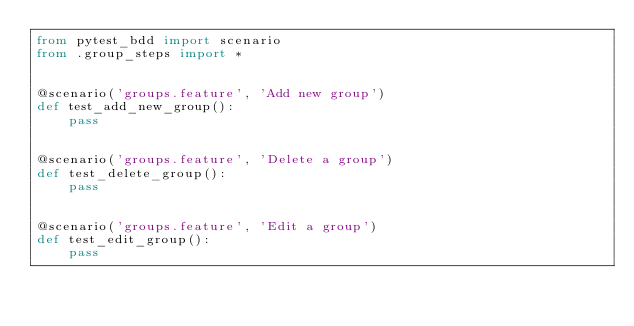Convert code to text. <code><loc_0><loc_0><loc_500><loc_500><_Python_>from pytest_bdd import scenario
from .group_steps import *


@scenario('groups.feature', 'Add new group')
def test_add_new_group():
    pass


@scenario('groups.feature', 'Delete a group')
def test_delete_group():
    pass


@scenario('groups.feature', 'Edit a group')
def test_edit_group():
    pass</code> 